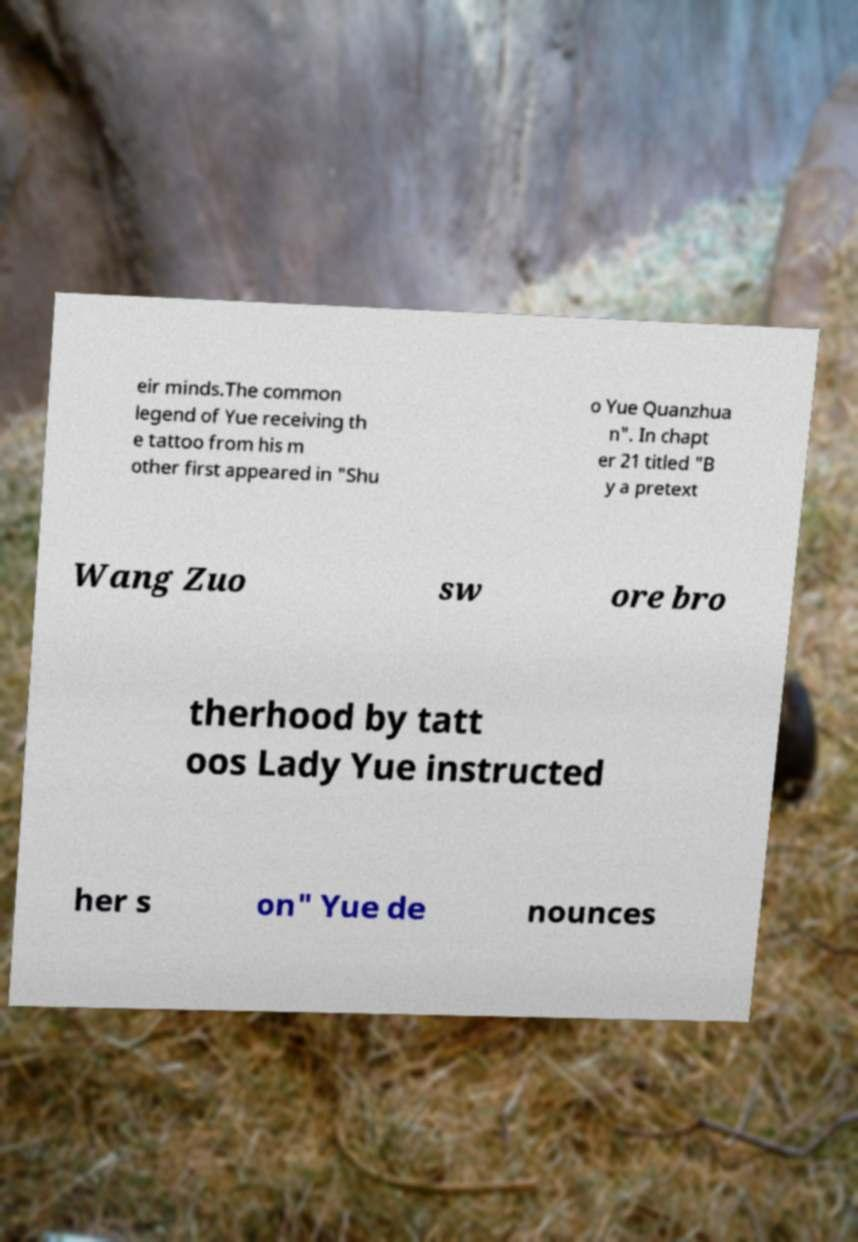I need the written content from this picture converted into text. Can you do that? eir minds.The common legend of Yue receiving th e tattoo from his m other first appeared in "Shu o Yue Quanzhua n". In chapt er 21 titled "B y a pretext Wang Zuo sw ore bro therhood by tatt oos Lady Yue instructed her s on" Yue de nounces 